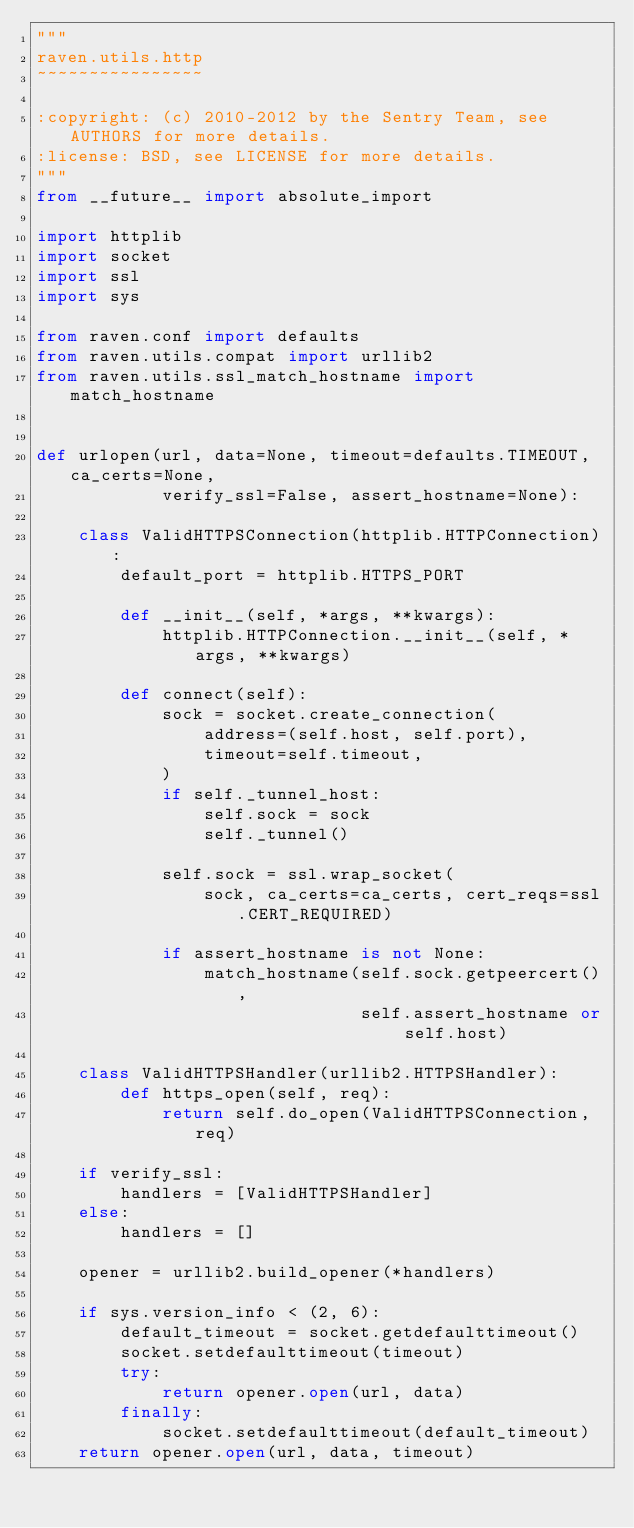<code> <loc_0><loc_0><loc_500><loc_500><_Python_>"""
raven.utils.http
~~~~~~~~~~~~~~~~

:copyright: (c) 2010-2012 by the Sentry Team, see AUTHORS for more details.
:license: BSD, see LICENSE for more details.
"""
from __future__ import absolute_import

import httplib
import socket
import ssl
import sys

from raven.conf import defaults
from raven.utils.compat import urllib2
from raven.utils.ssl_match_hostname import match_hostname


def urlopen(url, data=None, timeout=defaults.TIMEOUT, ca_certs=None,
            verify_ssl=False, assert_hostname=None):

    class ValidHTTPSConnection(httplib.HTTPConnection):
        default_port = httplib.HTTPS_PORT

        def __init__(self, *args, **kwargs):
            httplib.HTTPConnection.__init__(self, *args, **kwargs)

        def connect(self):
            sock = socket.create_connection(
                address=(self.host, self.port),
                timeout=self.timeout,
            )
            if self._tunnel_host:
                self.sock = sock
                self._tunnel()

            self.sock = ssl.wrap_socket(
                sock, ca_certs=ca_certs, cert_reqs=ssl.CERT_REQUIRED)

            if assert_hostname is not None:
                match_hostname(self.sock.getpeercert(),
                               self.assert_hostname or self.host)

    class ValidHTTPSHandler(urllib2.HTTPSHandler):
        def https_open(self, req):
            return self.do_open(ValidHTTPSConnection, req)

    if verify_ssl:
        handlers = [ValidHTTPSHandler]
    else:
        handlers = []

    opener = urllib2.build_opener(*handlers)

    if sys.version_info < (2, 6):
        default_timeout = socket.getdefaulttimeout()
        socket.setdefaulttimeout(timeout)
        try:
            return opener.open(url, data)
        finally:
            socket.setdefaulttimeout(default_timeout)
    return opener.open(url, data, timeout)
</code> 